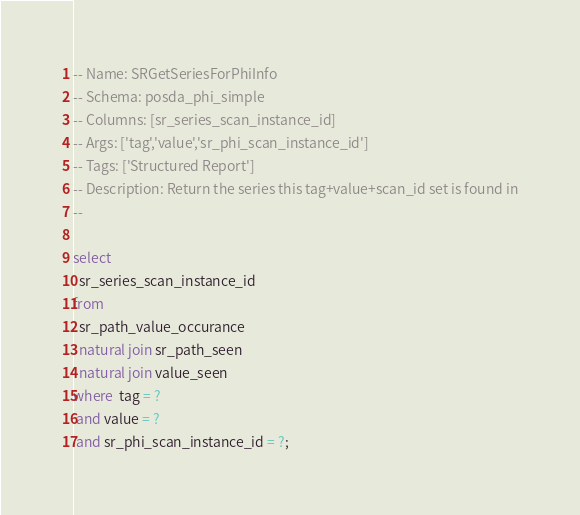<code> <loc_0><loc_0><loc_500><loc_500><_SQL_>-- Name: SRGetSeriesForPhiInfo
-- Schema: posda_phi_simple
-- Columns: [sr_series_scan_instance_id]
-- Args: ['tag','value','sr_phi_scan_instance_id']
-- Tags: ['Structured Report']
-- Description: Return the series this tag+value+scan_id set is found in
--

select
  sr_series_scan_instance_id
from
  sr_path_value_occurance
  natural join sr_path_seen
  natural join value_seen
where  tag = ?
 and value = ?
 and sr_phi_scan_instance_id = ?;
</code> 